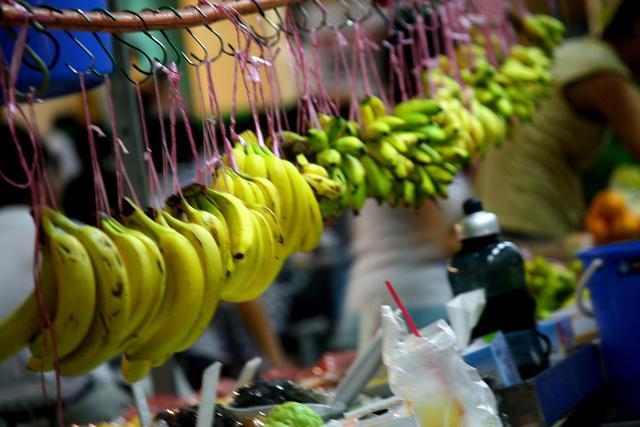Are the bananas ripe?
Short answer required. Yes. Is this a farmers market?
Give a very brief answer. Yes. Is this how bananas grow?
Give a very brief answer. No. Are the bananas in a store?
Give a very brief answer. Yes. What color is the fruit?
Give a very brief answer. Yellow. Is the fruit ripe?
Keep it brief. Yes. Are these bananas ready to eat?
Be succinct. Yes. 